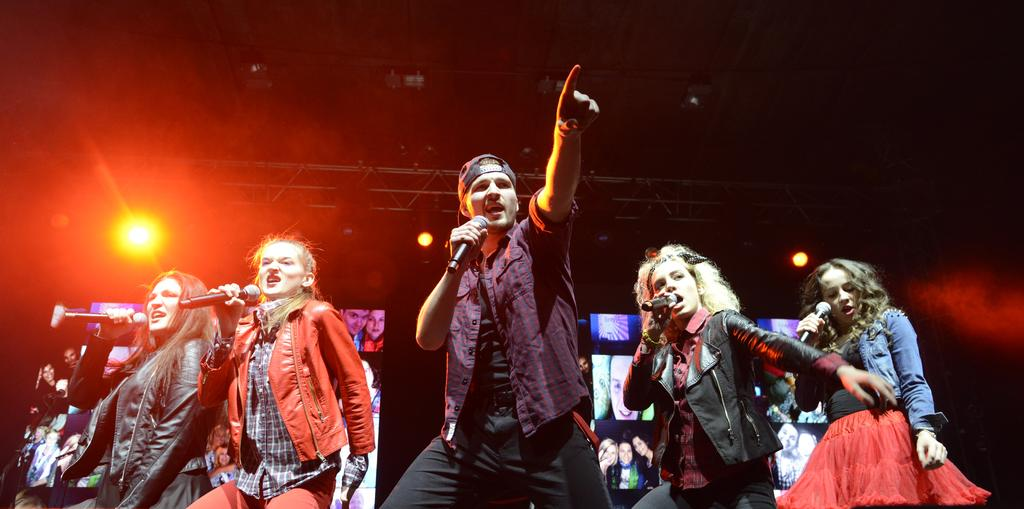How many people are in the image? There are two people in the image, a man and a woman. What are the man and woman doing in the image? The man and woman are standing and holding microphones. What is the man wearing on his head? The man is wearing a cap. What can be seen in the background of the image? There are stage lights in the background of the image. What type of dock can be seen in the image? There is no dock present in the image. What song are the man and woman singing in the image? The image does not provide any information about the song being sung by the man and woman. 